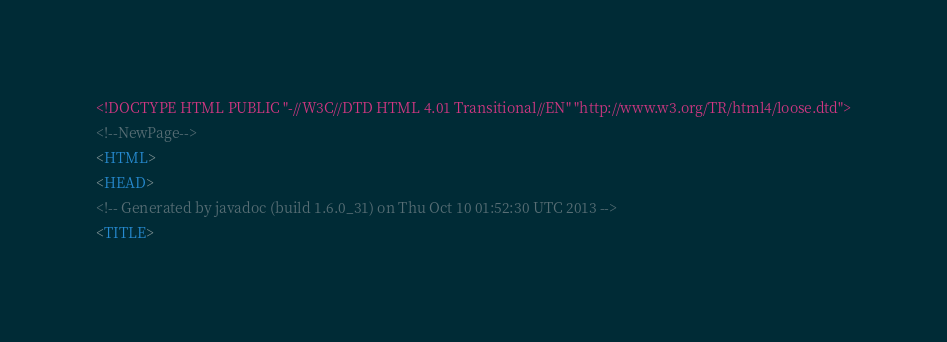<code> <loc_0><loc_0><loc_500><loc_500><_HTML_><!DOCTYPE HTML PUBLIC "-//W3C//DTD HTML 4.01 Transitional//EN" "http://www.w3.org/TR/html4/loose.dtd">
<!--NewPage-->
<HTML>
<HEAD>
<!-- Generated by javadoc (build 1.6.0_31) on Thu Oct 10 01:52:30 UTC 2013 -->
<TITLE></code> 